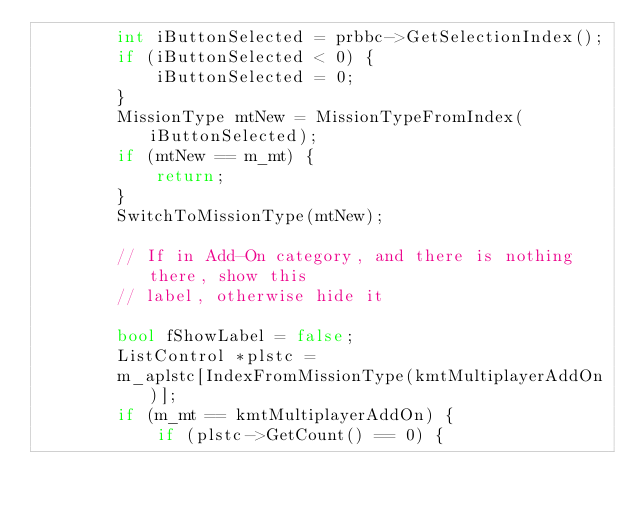Convert code to text. <code><loc_0><loc_0><loc_500><loc_500><_C++_>        int iButtonSelected = prbbc->GetSelectionIndex();
        if (iButtonSelected < 0) {
            iButtonSelected = 0;
        }
        MissionType mtNew = MissionTypeFromIndex(iButtonSelected);
        if (mtNew == m_mt) {
            return;
        }
        SwitchToMissionType(mtNew);
        
        // If in Add-On category, and there is nothing there, show this
        // label, otherwise hide it
        
        bool fShowLabel = false;
        ListControl *plstc =
        m_aplstc[IndexFromMissionType(kmtMultiplayerAddOn)];
        if (m_mt == kmtMultiplayerAddOn) {
            if (plstc->GetCount() == 0) {</code> 